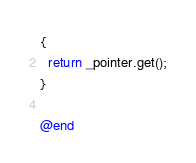<code> <loc_0><loc_0><loc_500><loc_500><_ObjectiveC_>{
  return _pointer.get();
}

@end
</code> 